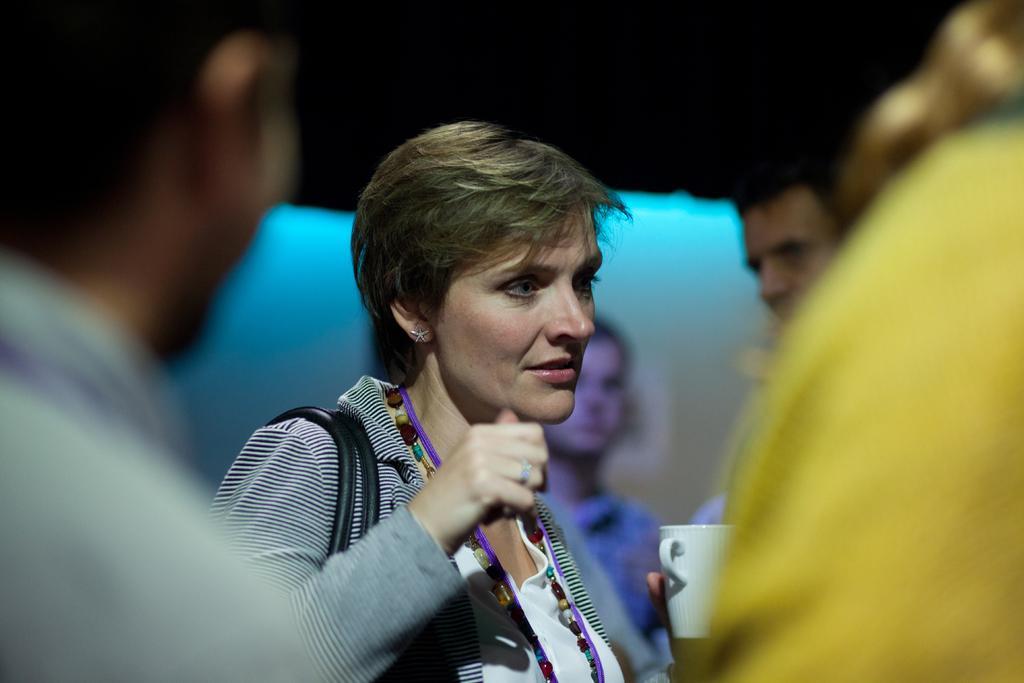In one or two sentences, can you explain what this image depicts? In the image we can see there are people standing and the woman is holding coffee mug in her hand. Only the woman is focused in the image. Background of the image is blurred. 